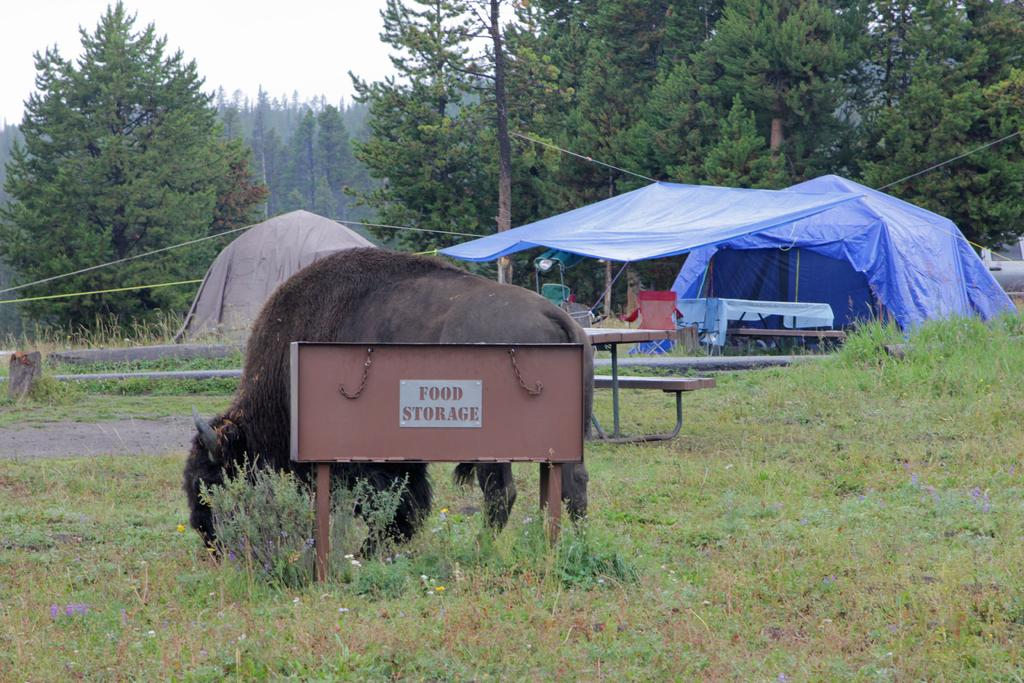What type of animal can be seen in the image? There is an animal in the image, but its specific type is not mentioned in the facts. What is the animal doing in the image? The animal is grazing in the grass. What can be seen in the background of the image? Trees are present in the image. What type of temporary shelter can be seen in the image? There are tents in the image. What is the animal's opinion on the chin of the person in the image? There is no person present in the image, so it is impossible to determine the animal's opinion on a chin. 